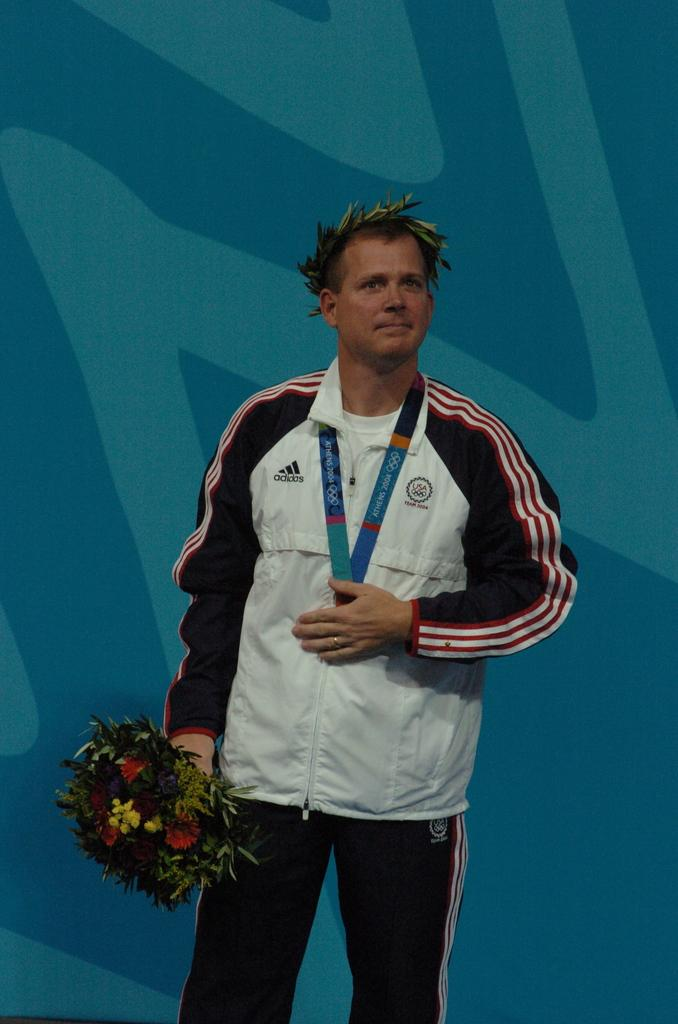Provide a one-sentence caption for the provided image. A man with an Athens 2004 Olympic medal hanging around his neck is holding a bouquet. 